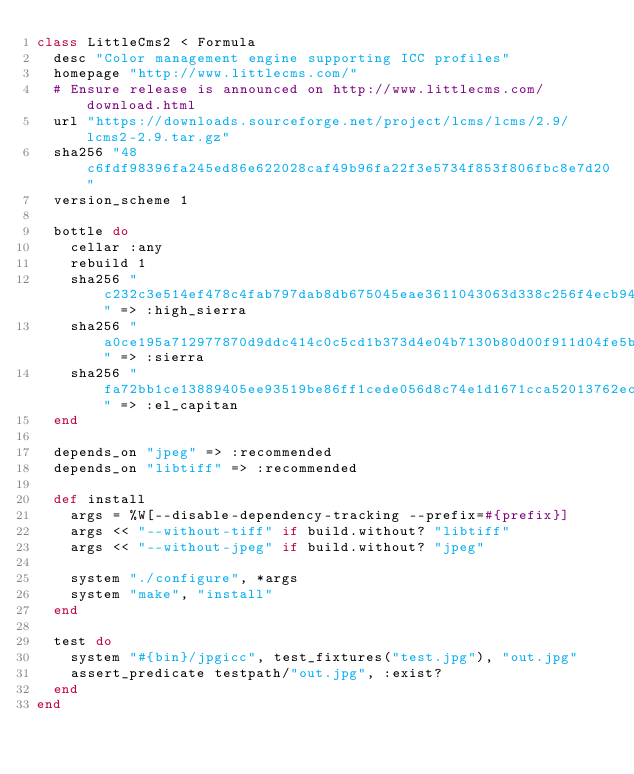Convert code to text. <code><loc_0><loc_0><loc_500><loc_500><_Ruby_>class LittleCms2 < Formula
  desc "Color management engine supporting ICC profiles"
  homepage "http://www.littlecms.com/"
  # Ensure release is announced on http://www.littlecms.com/download.html
  url "https://downloads.sourceforge.net/project/lcms/lcms/2.9/lcms2-2.9.tar.gz"
  sha256 "48c6fdf98396fa245ed86e622028caf49b96fa22f3e5734f853f806fbc8e7d20"
  version_scheme 1

  bottle do
    cellar :any
    rebuild 1
    sha256 "c232c3e514ef478c4fab797dab8db675045eae3611043063d338c256f4ecb941" => :high_sierra
    sha256 "a0ce195a712977870d9ddc414c0c5cd1b373d4e04b7130b80d00f911d04fe5b4" => :sierra
    sha256 "fa72bb1ce13889405ee93519be86ff1cede056d8c74e1d1671cca52013762ec0" => :el_capitan
  end

  depends_on "jpeg" => :recommended
  depends_on "libtiff" => :recommended

  def install
    args = %W[--disable-dependency-tracking --prefix=#{prefix}]
    args << "--without-tiff" if build.without? "libtiff"
    args << "--without-jpeg" if build.without? "jpeg"

    system "./configure", *args
    system "make", "install"
  end

  test do
    system "#{bin}/jpgicc", test_fixtures("test.jpg"), "out.jpg"
    assert_predicate testpath/"out.jpg", :exist?
  end
end
</code> 